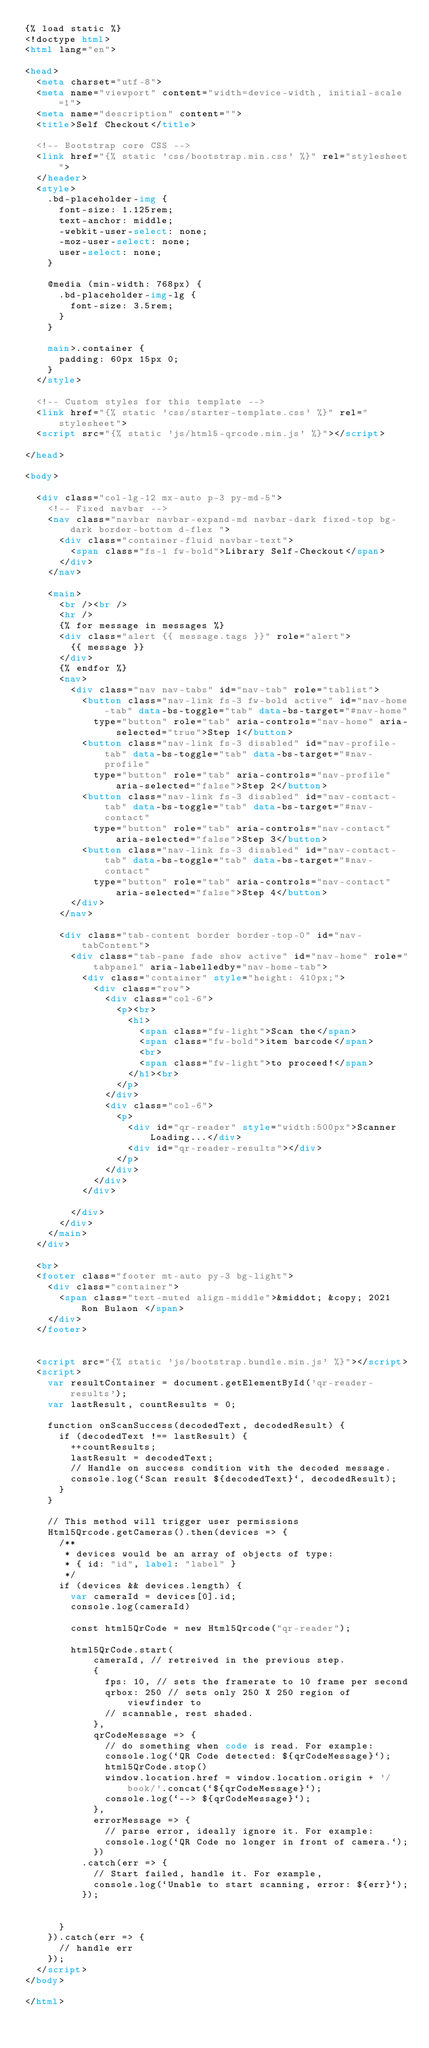Convert code to text. <code><loc_0><loc_0><loc_500><loc_500><_HTML_>{% load static %}
<!doctype html>
<html lang="en">

<head>
  <meta charset="utf-8">
  <meta name="viewport" content="width=device-width, initial-scale=1">
  <meta name="description" content="">
  <title>Self Checkout</title>

  <!-- Bootstrap core CSS -->
  <link href="{% static 'css/bootstrap.min.css' %}" rel="stylesheet">
  </header>
  <style>
    .bd-placeholder-img {
      font-size: 1.125rem;
      text-anchor: middle;
      -webkit-user-select: none;
      -moz-user-select: none;
      user-select: none;
    }

    @media (min-width: 768px) {
      .bd-placeholder-img-lg {
        font-size: 3.5rem;
      }
    }

    main>.container {
      padding: 60px 15px 0;
    }
  </style>

  <!-- Custom styles for this template -->
  <link href="{% static 'css/starter-template.css' %}" rel="stylesheet">
  <script src="{% static 'js/html5-qrcode.min.js' %}"></script>

</head>

<body>

  <div class="col-lg-12 mx-auto p-3 py-md-5">
    <!-- Fixed navbar -->
    <nav class="navbar navbar-expand-md navbar-dark fixed-top bg-dark border-bottom d-flex ">
      <div class="container-fluid navbar-text">
        <span class="fs-1 fw-bold">Library Self-Checkout</span>
      </div>
    </nav>

    <main>
      <br /><br />
      <hr />
      {% for message in messages %}
      <div class="alert {{ message.tags }}" role="alert">
        {{ message }}
      </div>
      {% endfor %}
      <nav>
        <div class="nav nav-tabs" id="nav-tab" role="tablist">
          <button class="nav-link fs-3 fw-bold active" id="nav-home-tab" data-bs-toggle="tab" data-bs-target="#nav-home"
            type="button" role="tab" aria-controls="nav-home" aria-selected="true">Step 1</button>
          <button class="nav-link fs-3 disabled" id="nav-profile-tab" data-bs-toggle="tab" data-bs-target="#nav-profile"
            type="button" role="tab" aria-controls="nav-profile" aria-selected="false">Step 2</button>
          <button class="nav-link fs-3 disabled" id="nav-contact-tab" data-bs-toggle="tab" data-bs-target="#nav-contact"
            type="button" role="tab" aria-controls="nav-contact" aria-selected="false">Step 3</button>
          <button class="nav-link fs-3 disabled" id="nav-contact-tab" data-bs-toggle="tab" data-bs-target="#nav-contact"
            type="button" role="tab" aria-controls="nav-contact" aria-selected="false">Step 4</button>
        </div>
      </nav>

      <div class="tab-content border border-top-0" id="nav-tabContent">
        <div class="tab-pane fade show active" id="nav-home" role="tabpanel" aria-labelledby="nav-home-tab">
          <div class="container" style="height: 410px;">
            <div class="row">
              <div class="col-6">
                <p><br>
                  <h1>
                    <span class="fw-light">Scan the</span>
                    <span class="fw-bold">item barcode</span>
                    <br>
                    <span class="fw-light">to proceed!</span>
                  </h1><br>
                </p>
              </div>
              <div class="col-6">
                <p>
                  <div id="qr-reader" style="width:500px">Scanner Loading...</div>
                  <div id="qr-reader-results"></div>
                </p>
              </div>
            </div>
          </div>

        </div>
      </div>
    </main>
  </div>

  <br>
  <footer class="footer mt-auto py-3 bg-light">
    <div class="container">
      <span class="text-muted align-middle">&middot; &copy; 2021 Ron Bulaon </span>
    </div>
  </footer>


  <script src="{% static 'js/bootstrap.bundle.min.js' %}"></script>
  <script>
    var resultContainer = document.getElementById('qr-reader-results');
    var lastResult, countResults = 0;

    function onScanSuccess(decodedText, decodedResult) {
      if (decodedText !== lastResult) {
        ++countResults;
        lastResult = decodedText;
        // Handle on success condition with the decoded message.
        console.log(`Scan result ${decodedText}`, decodedResult);
      }
    }

    // This method will trigger user permissions
    Html5Qrcode.getCameras().then(devices => {
      /**
       * devices would be an array of objects of type:
       * { id: "id", label: "label" }
       */
      if (devices && devices.length) {
        var cameraId = devices[0].id;
        console.log(cameraId)

        const html5QrCode = new Html5Qrcode("qr-reader");

        html5QrCode.start(
            cameraId, // retreived in the previous step.
            {
              fps: 10, // sets the framerate to 10 frame per second
              qrbox: 250 // sets only 250 X 250 region of viewfinder to
              // scannable, rest shaded.
            },
            qrCodeMessage => {
              // do something when code is read. For example:
              console.log(`QR Code detected: ${qrCodeMessage}`);
              html5QrCode.stop()
              window.location.href = window.location.origin + '/book/'.concat(`${qrCodeMessage}`);
              console.log(`--> ${qrCodeMessage}`);
            },
            errorMessage => {
              // parse error, ideally ignore it. For example:
              console.log(`QR Code no longer in front of camera.`);
            })
          .catch(err => {
            // Start failed, handle it. For example,
            console.log(`Unable to start scanning, error: ${err}`);
          });


      }
    }).catch(err => {
      // handle err
    });
  </script>
</body>

</html></code> 